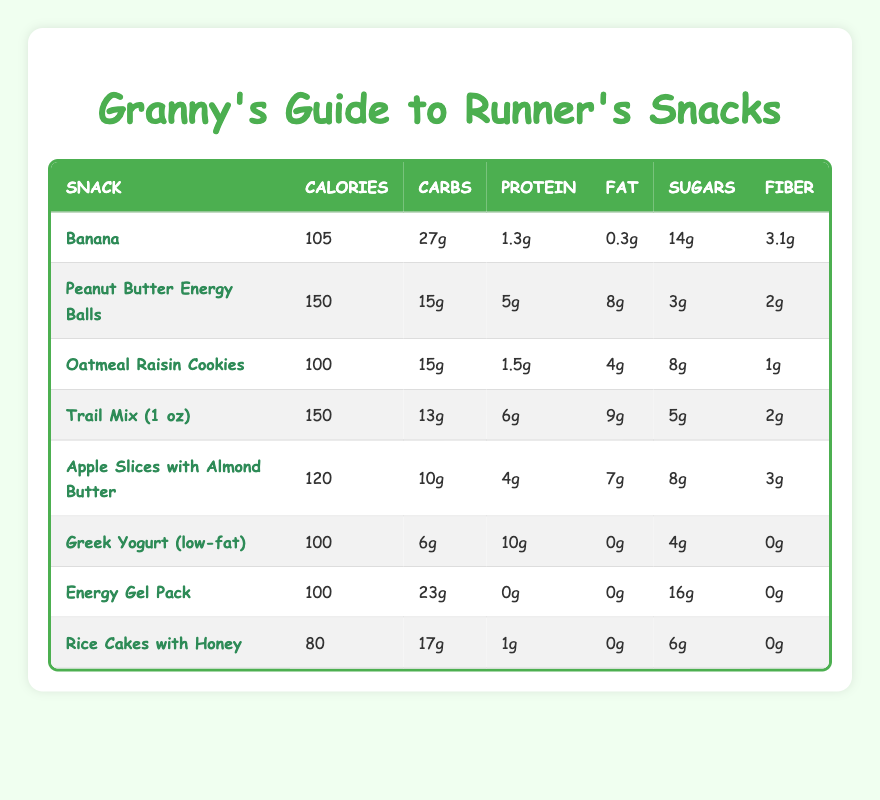What snack has the highest protein content? Looking at the protein content for each snack, Greek Yogurt (low-fat) has 10g, which is higher than the others.
Answer: Greek Yogurt (low-fat) How many calories are in Peanut Butter Energy Balls? The table directly states that Peanut Butter Energy Balls have 150 calories.
Answer: 150 calories Which snack has the least amount of fat? Checking the fat content, Greek Yogurt (low-fat) has 0g of fat, making it the snack with the least fat.
Answer: Greek Yogurt (low-fat) What is the total number of carbohydrates in Trail Mix and Oatmeal Raisin Cookies combined? Trail Mix contains 13g of carbohydrates and Oatmeal Raisin Cookies contain 15g. Adding them together gives 13 + 15 = 28g of carbohydrates.
Answer: 28g Is there any snack that has more sugars than Energy Gel Pack? The Energy Gel Pack has 16g of sugars, and comparing it with others, only Banana with 14g has less, while others have equal or more. The answer is false.
Answer: No What is the average number of calories in all the snacks listed? Adding the calories together gives a total of 105 + 150 + 100 + 150 + 120 + 100 + 100 + 80 = 905. There are 8 snacks, so the average is 905 / 8 = 113.125, which rounds to 113.
Answer: 113.125 Which snack provides the highest amount of fiber? By examining the fiber content across all snacks, Banana has the highest at 3.1g.
Answer: Banana How much more sugar does Energy Gel Pack have compared to Rice Cakes with Honey? Energy Gel Pack has 16g of sugars, while Rice Cakes with Honey has 6g. The difference is 16 - 6 = 10g.
Answer: 10g What percentage of calories from Protein does Greek Yogurt (low-fat) contain? It has 100 calories and 10g protein. To convert protein grams to calories, multiply by 4 (10g * 4 = 40 calories). So, (40 / 100) * 100 = 40%.
Answer: 40% What is the total fiber content of Apple Slices with Almond Butter and Trail Mix? Apple Slices with Almond Butter contains 3g of fiber, and Trail Mix has 2g. Adding them gives 3 + 2 = 5g of fiber total.
Answer: 5g 